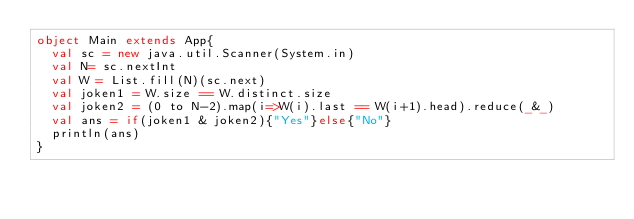<code> <loc_0><loc_0><loc_500><loc_500><_Scala_>object Main extends App{
  val sc = new java.util.Scanner(System.in)
  val N= sc.nextInt
  val W = List.fill(N)(sc.next)
  val joken1 = W.size == W.distinct.size
  val joken2 = (0 to N-2).map(i=>W(i).last == W(i+1).head).reduce(_&_)
  val ans = if(joken1 & joken2){"Yes"}else{"No"}
  println(ans)
}

</code> 